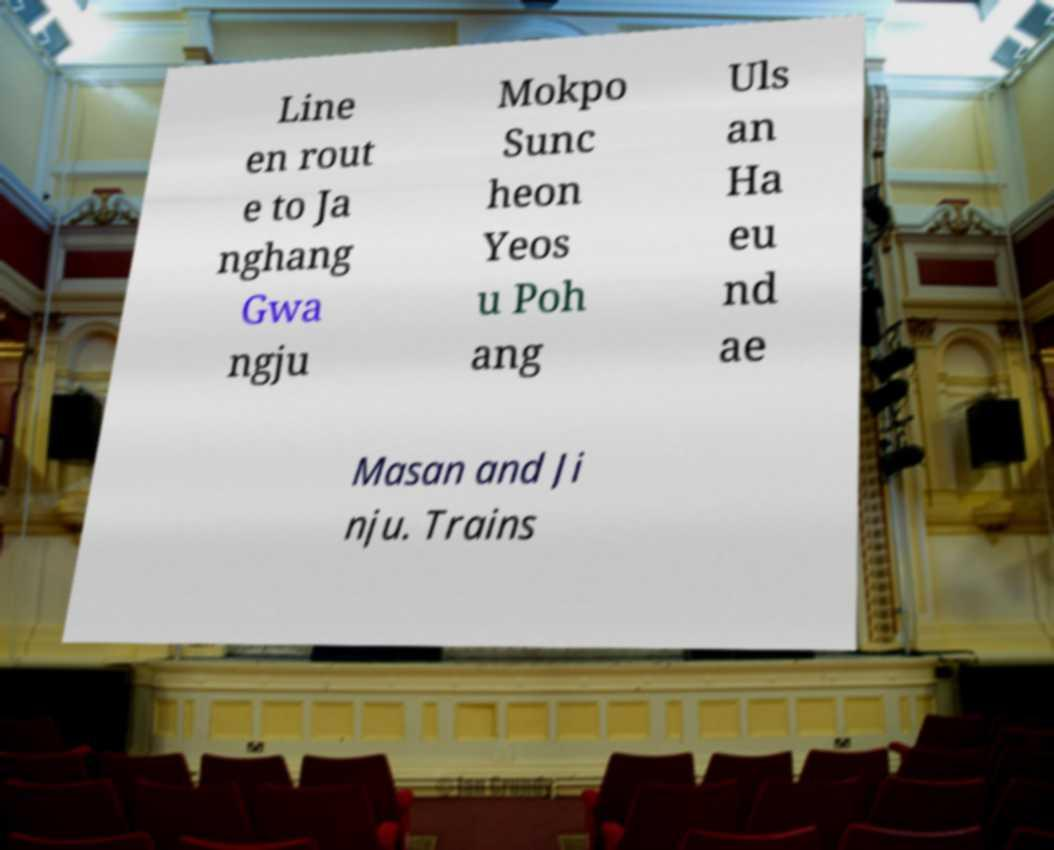Can you read and provide the text displayed in the image?This photo seems to have some interesting text. Can you extract and type it out for me? Line en rout e to Ja nghang Gwa ngju Mokpo Sunc heon Yeos u Poh ang Uls an Ha eu nd ae Masan and Ji nju. Trains 